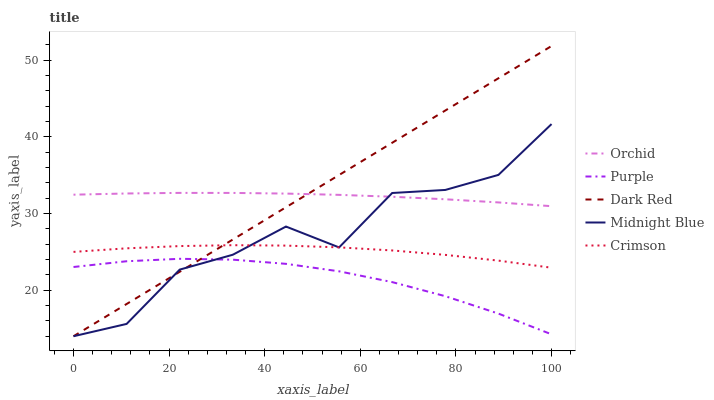Does Purple have the minimum area under the curve?
Answer yes or no. Yes. Does Dark Red have the maximum area under the curve?
Answer yes or no. Yes. Does Midnight Blue have the minimum area under the curve?
Answer yes or no. No. Does Midnight Blue have the maximum area under the curve?
Answer yes or no. No. Is Dark Red the smoothest?
Answer yes or no. Yes. Is Midnight Blue the roughest?
Answer yes or no. Yes. Is Midnight Blue the smoothest?
Answer yes or no. No. Is Dark Red the roughest?
Answer yes or no. No. Does Crimson have the lowest value?
Answer yes or no. No. Does Dark Red have the highest value?
Answer yes or no. Yes. Does Midnight Blue have the highest value?
Answer yes or no. No. Is Purple less than Orchid?
Answer yes or no. Yes. Is Crimson greater than Purple?
Answer yes or no. Yes. Does Orchid intersect Midnight Blue?
Answer yes or no. Yes. Is Orchid less than Midnight Blue?
Answer yes or no. No. Is Orchid greater than Midnight Blue?
Answer yes or no. No. Does Purple intersect Orchid?
Answer yes or no. No. 